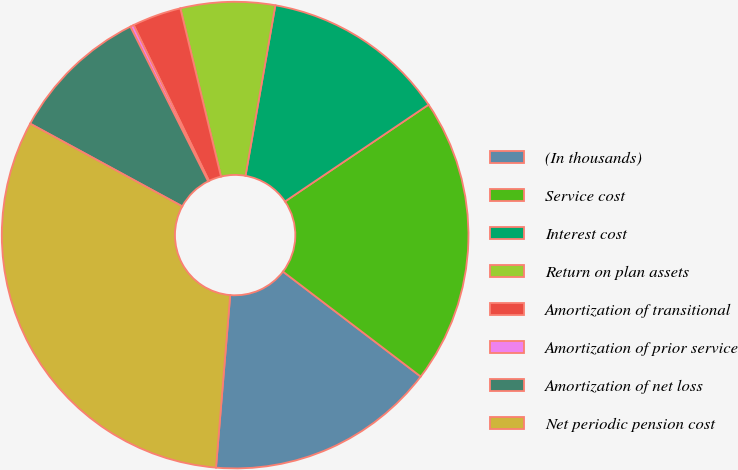Convert chart to OTSL. <chart><loc_0><loc_0><loc_500><loc_500><pie_chart><fcel>(In thousands)<fcel>Service cost<fcel>Interest cost<fcel>Return on plan assets<fcel>Amortization of transitional<fcel>Amortization of prior service<fcel>Amortization of net loss<fcel>Net periodic pension cost<nl><fcel>15.94%<fcel>19.81%<fcel>12.8%<fcel>6.53%<fcel>3.39%<fcel>0.25%<fcel>9.66%<fcel>31.62%<nl></chart> 